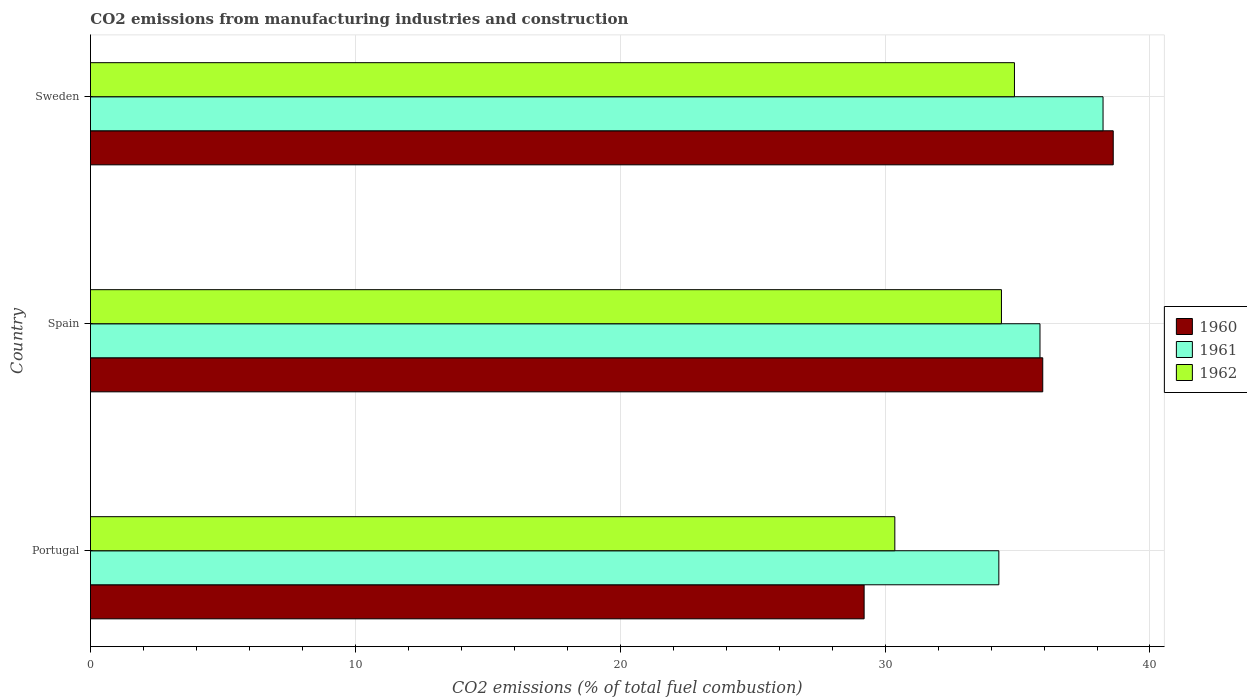How many groups of bars are there?
Offer a very short reply. 3. Are the number of bars per tick equal to the number of legend labels?
Your response must be concise. Yes. How many bars are there on the 1st tick from the top?
Your answer should be very brief. 3. How many bars are there on the 1st tick from the bottom?
Offer a terse response. 3. What is the amount of CO2 emitted in 1960 in Portugal?
Your response must be concise. 29.21. Across all countries, what is the maximum amount of CO2 emitted in 1961?
Provide a succinct answer. 38.23. Across all countries, what is the minimum amount of CO2 emitted in 1961?
Your response must be concise. 34.29. In which country was the amount of CO2 emitted in 1960 maximum?
Offer a terse response. Sweden. What is the total amount of CO2 emitted in 1962 in the graph?
Provide a succinct answer. 99.64. What is the difference between the amount of CO2 emitted in 1961 in Portugal and that in Spain?
Provide a succinct answer. -1.55. What is the difference between the amount of CO2 emitted in 1962 in Sweden and the amount of CO2 emitted in 1960 in Portugal?
Give a very brief answer. 5.68. What is the average amount of CO2 emitted in 1962 per country?
Ensure brevity in your answer.  33.21. What is the difference between the amount of CO2 emitted in 1960 and amount of CO2 emitted in 1962 in Spain?
Your answer should be very brief. 1.56. In how many countries, is the amount of CO2 emitted in 1961 greater than 4 %?
Offer a terse response. 3. What is the ratio of the amount of CO2 emitted in 1960 in Portugal to that in Spain?
Provide a succinct answer. 0.81. Is the difference between the amount of CO2 emitted in 1960 in Portugal and Sweden greater than the difference between the amount of CO2 emitted in 1962 in Portugal and Sweden?
Offer a terse response. No. What is the difference between the highest and the second highest amount of CO2 emitted in 1961?
Your response must be concise. 2.38. What is the difference between the highest and the lowest amount of CO2 emitted in 1961?
Your answer should be very brief. 3.93. What does the 1st bar from the top in Spain represents?
Provide a succinct answer. 1962. What does the 3rd bar from the bottom in Portugal represents?
Give a very brief answer. 1962. Is it the case that in every country, the sum of the amount of CO2 emitted in 1961 and amount of CO2 emitted in 1960 is greater than the amount of CO2 emitted in 1962?
Ensure brevity in your answer.  Yes. How many bars are there?
Make the answer very short. 9. Are all the bars in the graph horizontal?
Your answer should be very brief. Yes. How many countries are there in the graph?
Provide a short and direct response. 3. What is the difference between two consecutive major ticks on the X-axis?
Make the answer very short. 10. Does the graph contain any zero values?
Give a very brief answer. No. Does the graph contain grids?
Your response must be concise. Yes. How are the legend labels stacked?
Your answer should be very brief. Vertical. What is the title of the graph?
Your answer should be compact. CO2 emissions from manufacturing industries and construction. What is the label or title of the X-axis?
Your answer should be compact. CO2 emissions (% of total fuel combustion). What is the label or title of the Y-axis?
Make the answer very short. Country. What is the CO2 emissions (% of total fuel combustion) of 1960 in Portugal?
Provide a succinct answer. 29.21. What is the CO2 emissions (% of total fuel combustion) in 1961 in Portugal?
Keep it short and to the point. 34.29. What is the CO2 emissions (% of total fuel combustion) of 1962 in Portugal?
Ensure brevity in your answer.  30.37. What is the CO2 emissions (% of total fuel combustion) of 1960 in Spain?
Your answer should be compact. 35.95. What is the CO2 emissions (% of total fuel combustion) of 1961 in Spain?
Your answer should be very brief. 35.85. What is the CO2 emissions (% of total fuel combustion) in 1962 in Spain?
Your response must be concise. 34.39. What is the CO2 emissions (% of total fuel combustion) in 1960 in Sweden?
Your response must be concise. 38.61. What is the CO2 emissions (% of total fuel combustion) of 1961 in Sweden?
Give a very brief answer. 38.23. What is the CO2 emissions (% of total fuel combustion) in 1962 in Sweden?
Provide a short and direct response. 34.88. Across all countries, what is the maximum CO2 emissions (% of total fuel combustion) of 1960?
Give a very brief answer. 38.61. Across all countries, what is the maximum CO2 emissions (% of total fuel combustion) in 1961?
Make the answer very short. 38.23. Across all countries, what is the maximum CO2 emissions (% of total fuel combustion) in 1962?
Make the answer very short. 34.88. Across all countries, what is the minimum CO2 emissions (% of total fuel combustion) in 1960?
Ensure brevity in your answer.  29.21. Across all countries, what is the minimum CO2 emissions (% of total fuel combustion) in 1961?
Your answer should be compact. 34.29. Across all countries, what is the minimum CO2 emissions (% of total fuel combustion) of 1962?
Offer a terse response. 30.37. What is the total CO2 emissions (% of total fuel combustion) of 1960 in the graph?
Your answer should be very brief. 103.77. What is the total CO2 emissions (% of total fuel combustion) in 1961 in the graph?
Keep it short and to the point. 108.37. What is the total CO2 emissions (% of total fuel combustion) of 1962 in the graph?
Your response must be concise. 99.64. What is the difference between the CO2 emissions (% of total fuel combustion) of 1960 in Portugal and that in Spain?
Provide a succinct answer. -6.74. What is the difference between the CO2 emissions (% of total fuel combustion) of 1961 in Portugal and that in Spain?
Make the answer very short. -1.55. What is the difference between the CO2 emissions (% of total fuel combustion) in 1962 in Portugal and that in Spain?
Offer a very short reply. -4.03. What is the difference between the CO2 emissions (% of total fuel combustion) in 1960 in Portugal and that in Sweden?
Provide a short and direct response. -9.4. What is the difference between the CO2 emissions (% of total fuel combustion) of 1961 in Portugal and that in Sweden?
Provide a short and direct response. -3.93. What is the difference between the CO2 emissions (% of total fuel combustion) in 1962 in Portugal and that in Sweden?
Provide a short and direct response. -4.52. What is the difference between the CO2 emissions (% of total fuel combustion) in 1960 in Spain and that in Sweden?
Your answer should be compact. -2.66. What is the difference between the CO2 emissions (% of total fuel combustion) in 1961 in Spain and that in Sweden?
Give a very brief answer. -2.38. What is the difference between the CO2 emissions (% of total fuel combustion) in 1962 in Spain and that in Sweden?
Make the answer very short. -0.49. What is the difference between the CO2 emissions (% of total fuel combustion) in 1960 in Portugal and the CO2 emissions (% of total fuel combustion) in 1961 in Spain?
Make the answer very short. -6.64. What is the difference between the CO2 emissions (% of total fuel combustion) in 1960 in Portugal and the CO2 emissions (% of total fuel combustion) in 1962 in Spain?
Make the answer very short. -5.18. What is the difference between the CO2 emissions (% of total fuel combustion) in 1961 in Portugal and the CO2 emissions (% of total fuel combustion) in 1962 in Spain?
Offer a terse response. -0.1. What is the difference between the CO2 emissions (% of total fuel combustion) of 1960 in Portugal and the CO2 emissions (% of total fuel combustion) of 1961 in Sweden?
Offer a terse response. -9.02. What is the difference between the CO2 emissions (% of total fuel combustion) of 1960 in Portugal and the CO2 emissions (% of total fuel combustion) of 1962 in Sweden?
Give a very brief answer. -5.68. What is the difference between the CO2 emissions (% of total fuel combustion) in 1961 in Portugal and the CO2 emissions (% of total fuel combustion) in 1962 in Sweden?
Your answer should be compact. -0.59. What is the difference between the CO2 emissions (% of total fuel combustion) of 1960 in Spain and the CO2 emissions (% of total fuel combustion) of 1961 in Sweden?
Your answer should be compact. -2.28. What is the difference between the CO2 emissions (% of total fuel combustion) of 1960 in Spain and the CO2 emissions (% of total fuel combustion) of 1962 in Sweden?
Your answer should be very brief. 1.07. What is the difference between the CO2 emissions (% of total fuel combustion) in 1961 in Spain and the CO2 emissions (% of total fuel combustion) in 1962 in Sweden?
Ensure brevity in your answer.  0.96. What is the average CO2 emissions (% of total fuel combustion) in 1960 per country?
Your answer should be compact. 34.59. What is the average CO2 emissions (% of total fuel combustion) in 1961 per country?
Make the answer very short. 36.12. What is the average CO2 emissions (% of total fuel combustion) in 1962 per country?
Make the answer very short. 33.21. What is the difference between the CO2 emissions (% of total fuel combustion) of 1960 and CO2 emissions (% of total fuel combustion) of 1961 in Portugal?
Provide a short and direct response. -5.09. What is the difference between the CO2 emissions (% of total fuel combustion) of 1960 and CO2 emissions (% of total fuel combustion) of 1962 in Portugal?
Your response must be concise. -1.16. What is the difference between the CO2 emissions (% of total fuel combustion) of 1961 and CO2 emissions (% of total fuel combustion) of 1962 in Portugal?
Your response must be concise. 3.93. What is the difference between the CO2 emissions (% of total fuel combustion) in 1960 and CO2 emissions (% of total fuel combustion) in 1961 in Spain?
Give a very brief answer. 0.1. What is the difference between the CO2 emissions (% of total fuel combustion) of 1960 and CO2 emissions (% of total fuel combustion) of 1962 in Spain?
Your answer should be very brief. 1.56. What is the difference between the CO2 emissions (% of total fuel combustion) in 1961 and CO2 emissions (% of total fuel combustion) in 1962 in Spain?
Ensure brevity in your answer.  1.45. What is the difference between the CO2 emissions (% of total fuel combustion) in 1960 and CO2 emissions (% of total fuel combustion) in 1961 in Sweden?
Your answer should be very brief. 0.38. What is the difference between the CO2 emissions (% of total fuel combustion) in 1960 and CO2 emissions (% of total fuel combustion) in 1962 in Sweden?
Offer a very short reply. 3.73. What is the difference between the CO2 emissions (% of total fuel combustion) of 1961 and CO2 emissions (% of total fuel combustion) of 1962 in Sweden?
Provide a succinct answer. 3.35. What is the ratio of the CO2 emissions (% of total fuel combustion) in 1960 in Portugal to that in Spain?
Make the answer very short. 0.81. What is the ratio of the CO2 emissions (% of total fuel combustion) of 1961 in Portugal to that in Spain?
Give a very brief answer. 0.96. What is the ratio of the CO2 emissions (% of total fuel combustion) of 1962 in Portugal to that in Spain?
Make the answer very short. 0.88. What is the ratio of the CO2 emissions (% of total fuel combustion) of 1960 in Portugal to that in Sweden?
Offer a very short reply. 0.76. What is the ratio of the CO2 emissions (% of total fuel combustion) in 1961 in Portugal to that in Sweden?
Your answer should be very brief. 0.9. What is the ratio of the CO2 emissions (% of total fuel combustion) of 1962 in Portugal to that in Sweden?
Your answer should be very brief. 0.87. What is the ratio of the CO2 emissions (% of total fuel combustion) of 1960 in Spain to that in Sweden?
Ensure brevity in your answer.  0.93. What is the ratio of the CO2 emissions (% of total fuel combustion) in 1961 in Spain to that in Sweden?
Your answer should be compact. 0.94. What is the ratio of the CO2 emissions (% of total fuel combustion) of 1962 in Spain to that in Sweden?
Your answer should be compact. 0.99. What is the difference between the highest and the second highest CO2 emissions (% of total fuel combustion) of 1960?
Offer a very short reply. 2.66. What is the difference between the highest and the second highest CO2 emissions (% of total fuel combustion) of 1961?
Make the answer very short. 2.38. What is the difference between the highest and the second highest CO2 emissions (% of total fuel combustion) of 1962?
Your answer should be very brief. 0.49. What is the difference between the highest and the lowest CO2 emissions (% of total fuel combustion) in 1960?
Your answer should be very brief. 9.4. What is the difference between the highest and the lowest CO2 emissions (% of total fuel combustion) in 1961?
Offer a terse response. 3.93. What is the difference between the highest and the lowest CO2 emissions (% of total fuel combustion) of 1962?
Provide a short and direct response. 4.52. 